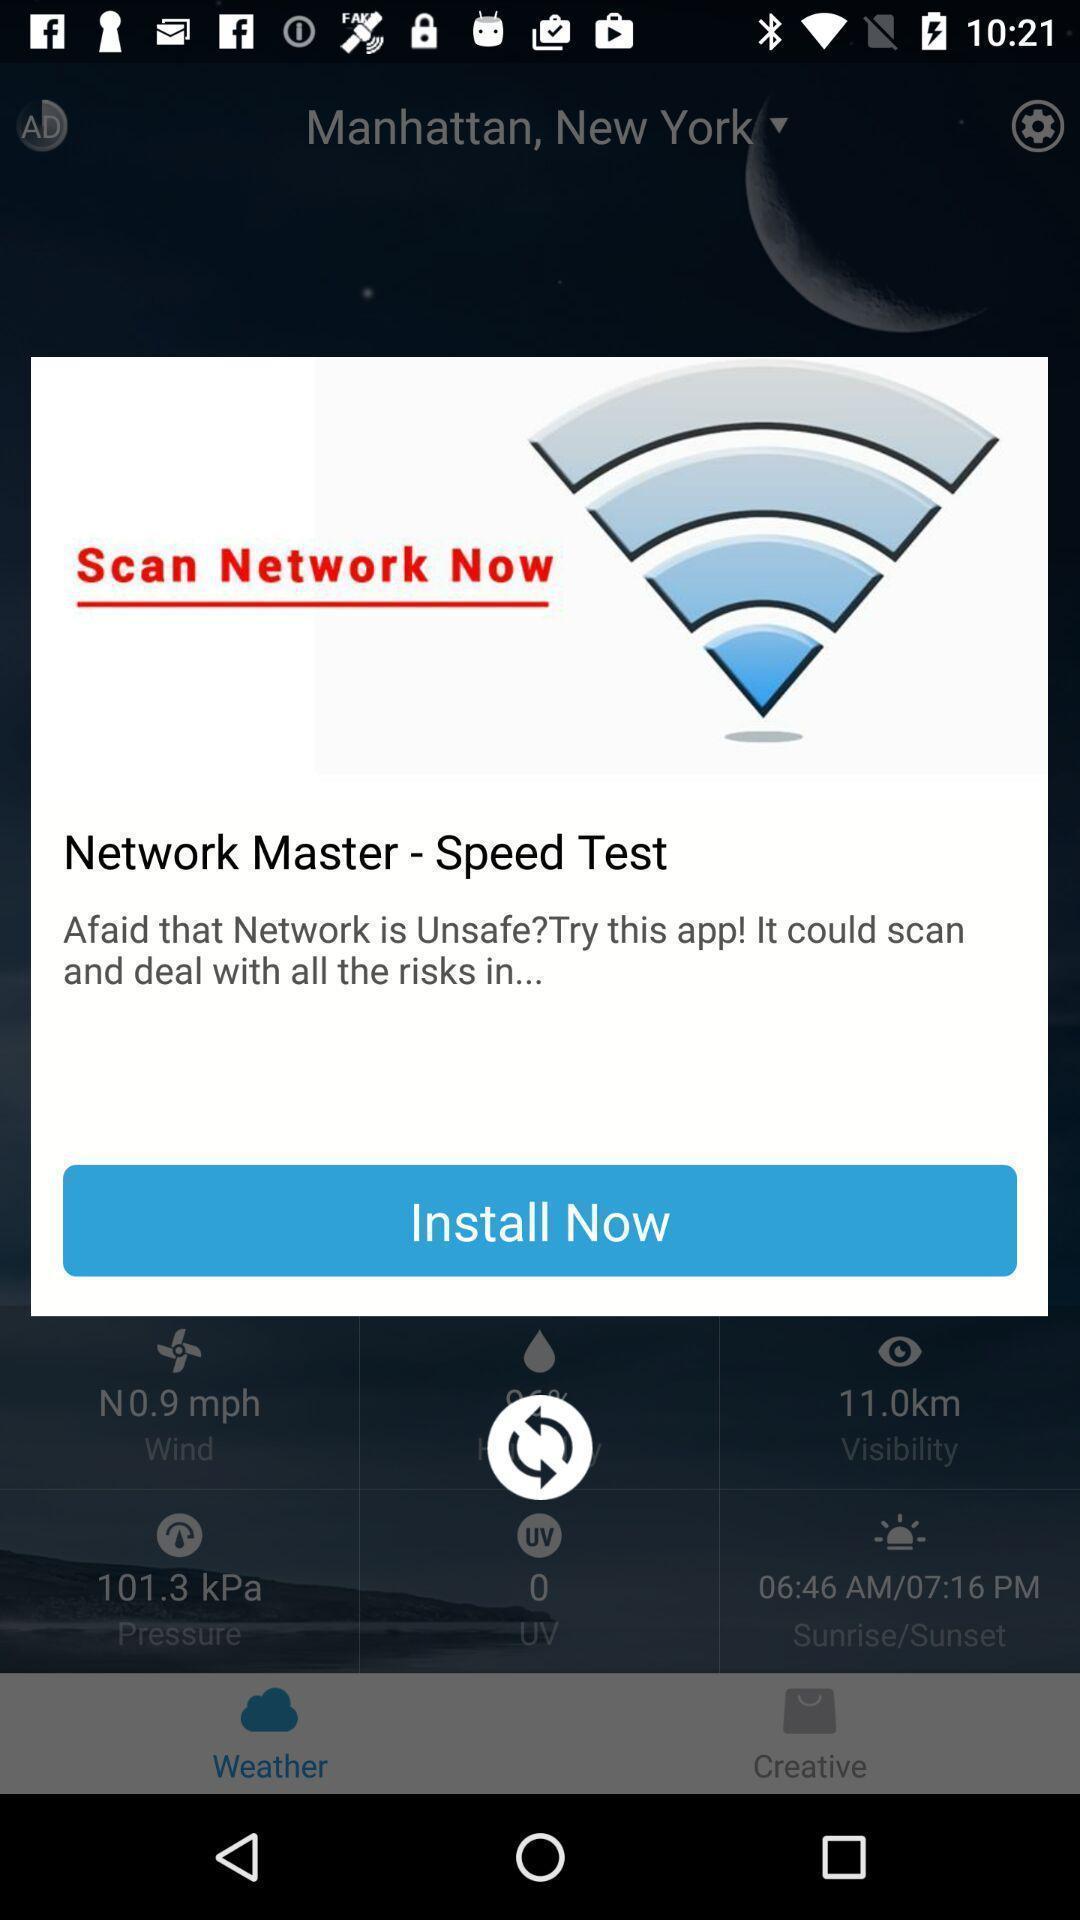Tell me about the visual elements in this screen capture. Pop-up showing to install a network speed test application. 